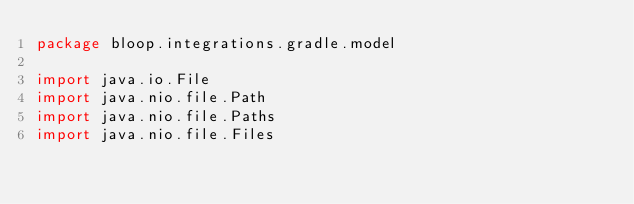Convert code to text. <code><loc_0><loc_0><loc_500><loc_500><_Scala_>package bloop.integrations.gradle.model

import java.io.File
import java.nio.file.Path
import java.nio.file.Paths
import java.nio.file.Files
</code> 